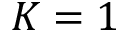Convert formula to latex. <formula><loc_0><loc_0><loc_500><loc_500>K = 1</formula> 